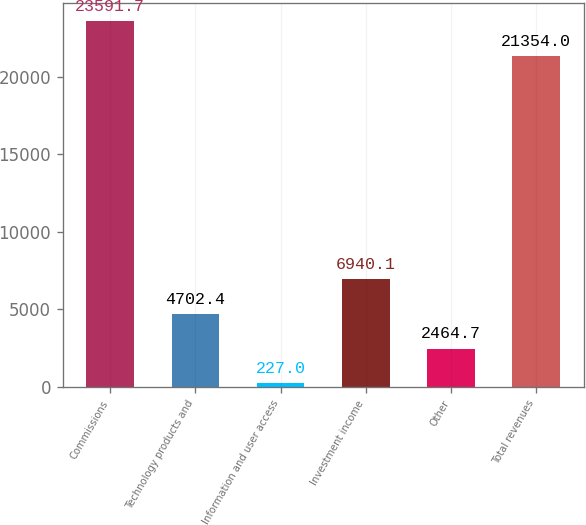<chart> <loc_0><loc_0><loc_500><loc_500><bar_chart><fcel>Commissions<fcel>Technology products and<fcel>Information and user access<fcel>Investment income<fcel>Other<fcel>Total revenues<nl><fcel>23591.7<fcel>4702.4<fcel>227<fcel>6940.1<fcel>2464.7<fcel>21354<nl></chart> 